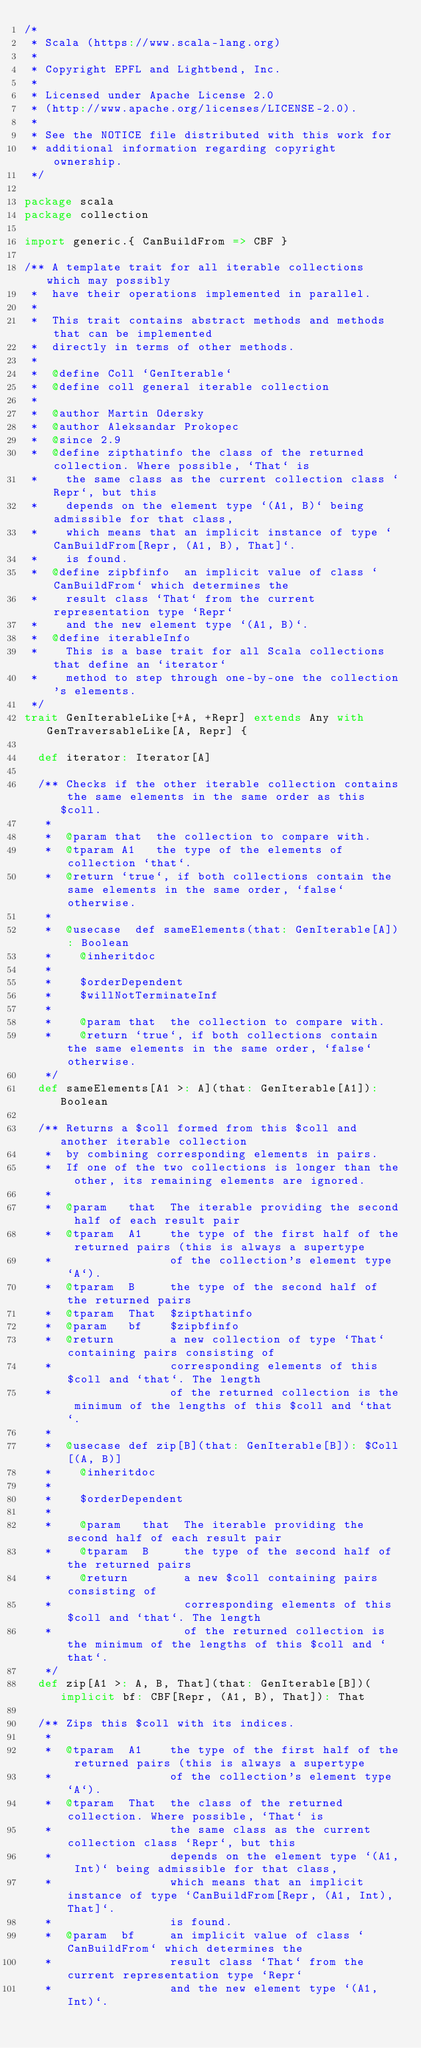Convert code to text. <code><loc_0><loc_0><loc_500><loc_500><_Scala_>/*
 * Scala (https://www.scala-lang.org)
 *
 * Copyright EPFL and Lightbend, Inc.
 *
 * Licensed under Apache License 2.0
 * (http://www.apache.org/licenses/LICENSE-2.0).
 *
 * See the NOTICE file distributed with this work for
 * additional information regarding copyright ownership.
 */

package scala
package collection

import generic.{ CanBuildFrom => CBF }

/** A template trait for all iterable collections which may possibly
 *  have their operations implemented in parallel.
 *
 *  This trait contains abstract methods and methods that can be implemented
 *  directly in terms of other methods.
 *
 *  @define Coll `GenIterable`
 *  @define coll general iterable collection
 *
 *  @author Martin Odersky
 *  @author Aleksandar Prokopec
 *  @since 2.9
 *  @define zipthatinfo the class of the returned collection. Where possible, `That` is
 *    the same class as the current collection class `Repr`, but this
 *    depends on the element type `(A1, B)` being admissible for that class,
 *    which means that an implicit instance of type `CanBuildFrom[Repr, (A1, B), That]`.
 *    is found.
 *  @define zipbfinfo  an implicit value of class `CanBuildFrom` which determines the
 *    result class `That` from the current representation type `Repr`
 *    and the new element type `(A1, B)`.
 *  @define iterableInfo
 *    This is a base trait for all Scala collections that define an `iterator`
 *    method to step through one-by-one the collection's elements.
 */
trait GenIterableLike[+A, +Repr] extends Any with GenTraversableLike[A, Repr] {

  def iterator: Iterator[A]

  /** Checks if the other iterable collection contains the same elements in the same order as this $coll.
   *
   *  @param that  the collection to compare with.
   *  @tparam A1   the type of the elements of collection `that`.
   *  @return `true`, if both collections contain the same elements in the same order, `false` otherwise.
   *
   *  @usecase  def sameElements(that: GenIterable[A]): Boolean
   *    @inheritdoc
   *
   *    $orderDependent
   *    $willNotTerminateInf
   *
   *    @param that  the collection to compare with.
   *    @return `true`, if both collections contain the same elements in the same order, `false` otherwise.
   */
  def sameElements[A1 >: A](that: GenIterable[A1]): Boolean

  /** Returns a $coll formed from this $coll and another iterable collection
   *  by combining corresponding elements in pairs.
   *  If one of the two collections is longer than the other, its remaining elements are ignored.
   *
   *  @param   that  The iterable providing the second half of each result pair
   *  @tparam  A1    the type of the first half of the returned pairs (this is always a supertype
   *                 of the collection's element type `A`).
   *  @tparam  B     the type of the second half of the returned pairs
   *  @tparam  That  $zipthatinfo
   *  @param   bf    $zipbfinfo
   *  @return        a new collection of type `That` containing pairs consisting of
   *                 corresponding elements of this $coll and `that`. The length
   *                 of the returned collection is the minimum of the lengths of this $coll and `that`.
   *
   *  @usecase def zip[B](that: GenIterable[B]): $Coll[(A, B)]
   *    @inheritdoc
   *
   *    $orderDependent
   *
   *    @param   that  The iterable providing the second half of each result pair
   *    @tparam  B     the type of the second half of the returned pairs
   *    @return        a new $coll containing pairs consisting of
   *                   corresponding elements of this $coll and `that`. The length
   *                   of the returned collection is the minimum of the lengths of this $coll and `that`.
   */
  def zip[A1 >: A, B, That](that: GenIterable[B])(implicit bf: CBF[Repr, (A1, B), That]): That

  /** Zips this $coll with its indices.
   *
   *  @tparam  A1    the type of the first half of the returned pairs (this is always a supertype
   *                 of the collection's element type `A`).
   *  @tparam  That  the class of the returned collection. Where possible, `That` is
   *                 the same class as the current collection class `Repr`, but this
   *                 depends on the element type `(A1, Int)` being admissible for that class,
   *                 which means that an implicit instance of type `CanBuildFrom[Repr, (A1, Int), That]`.
   *                 is found.
   *  @param  bf     an implicit value of class `CanBuildFrom` which determines the
   *                 result class `That` from the current representation type `Repr`
   *                 and the new element type `(A1, Int)`.</code> 